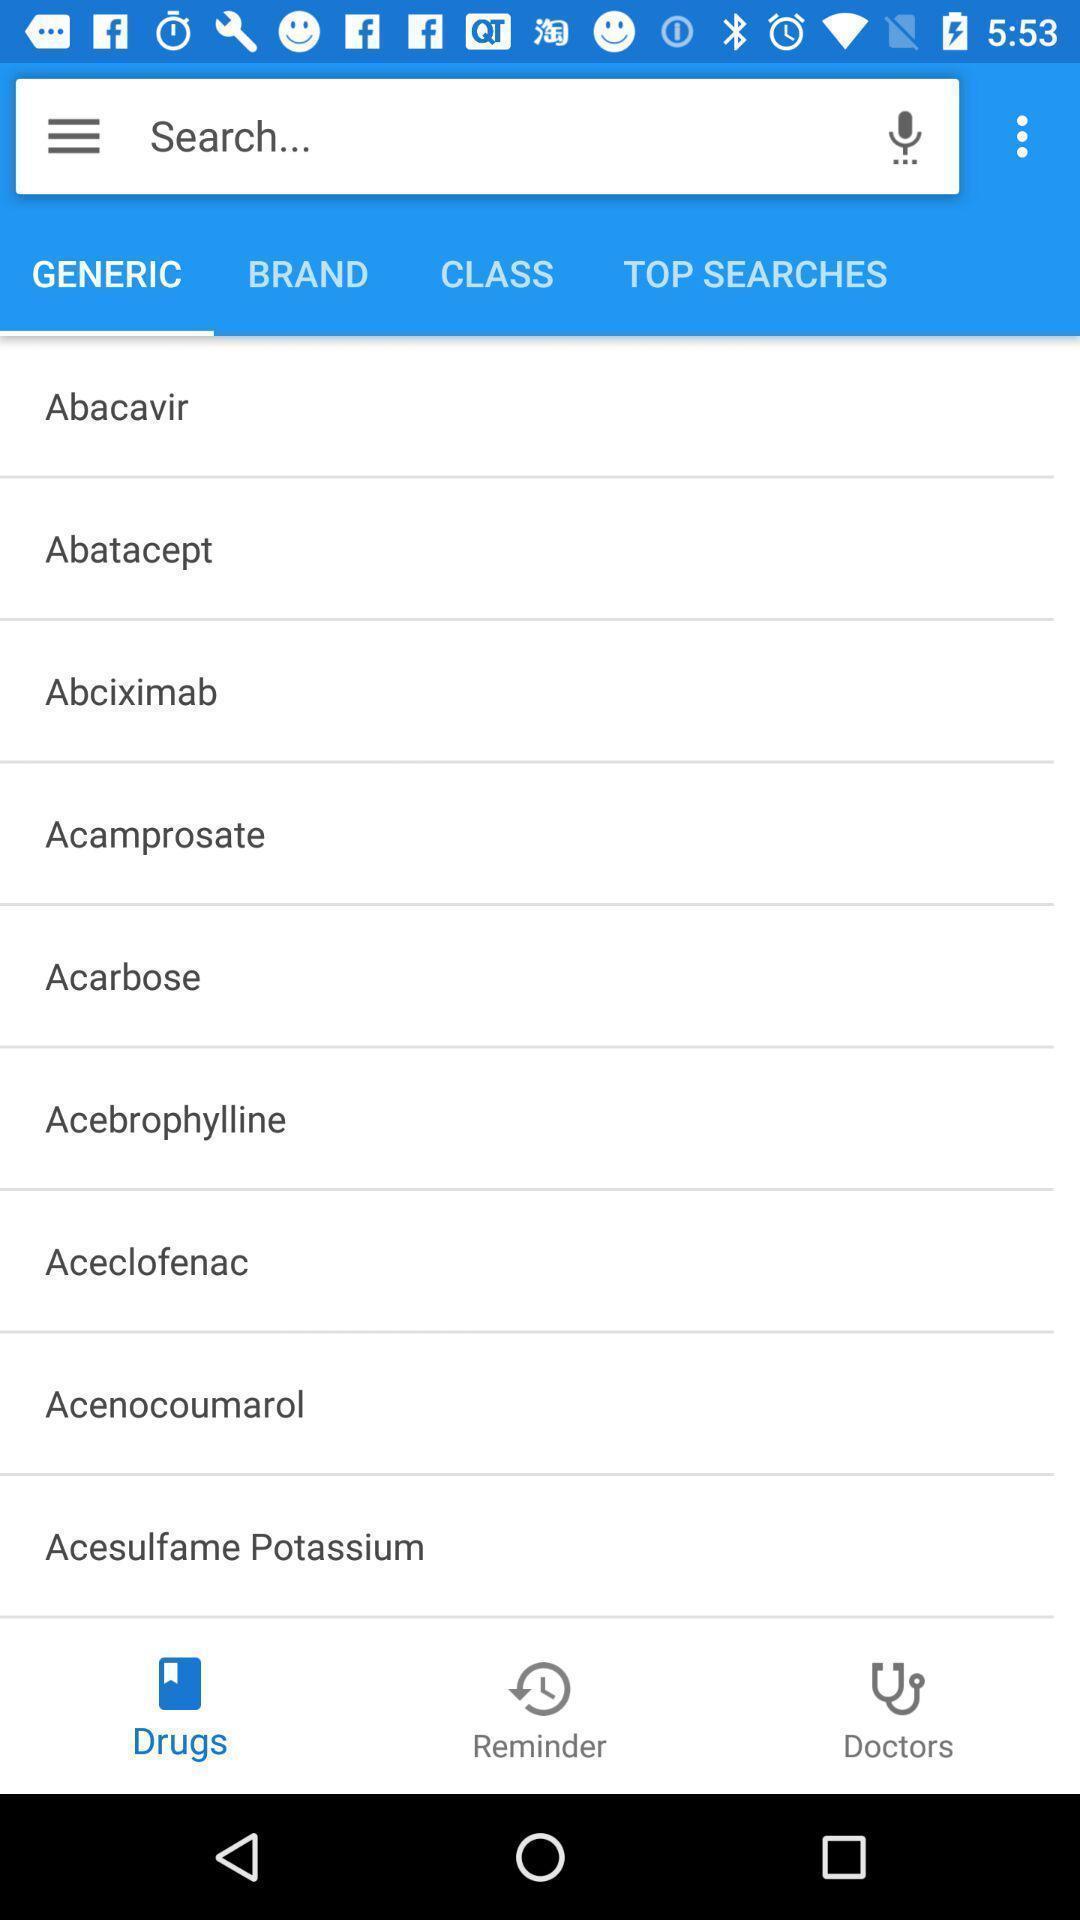Please provide a description for this image. Search page to find drugs. 